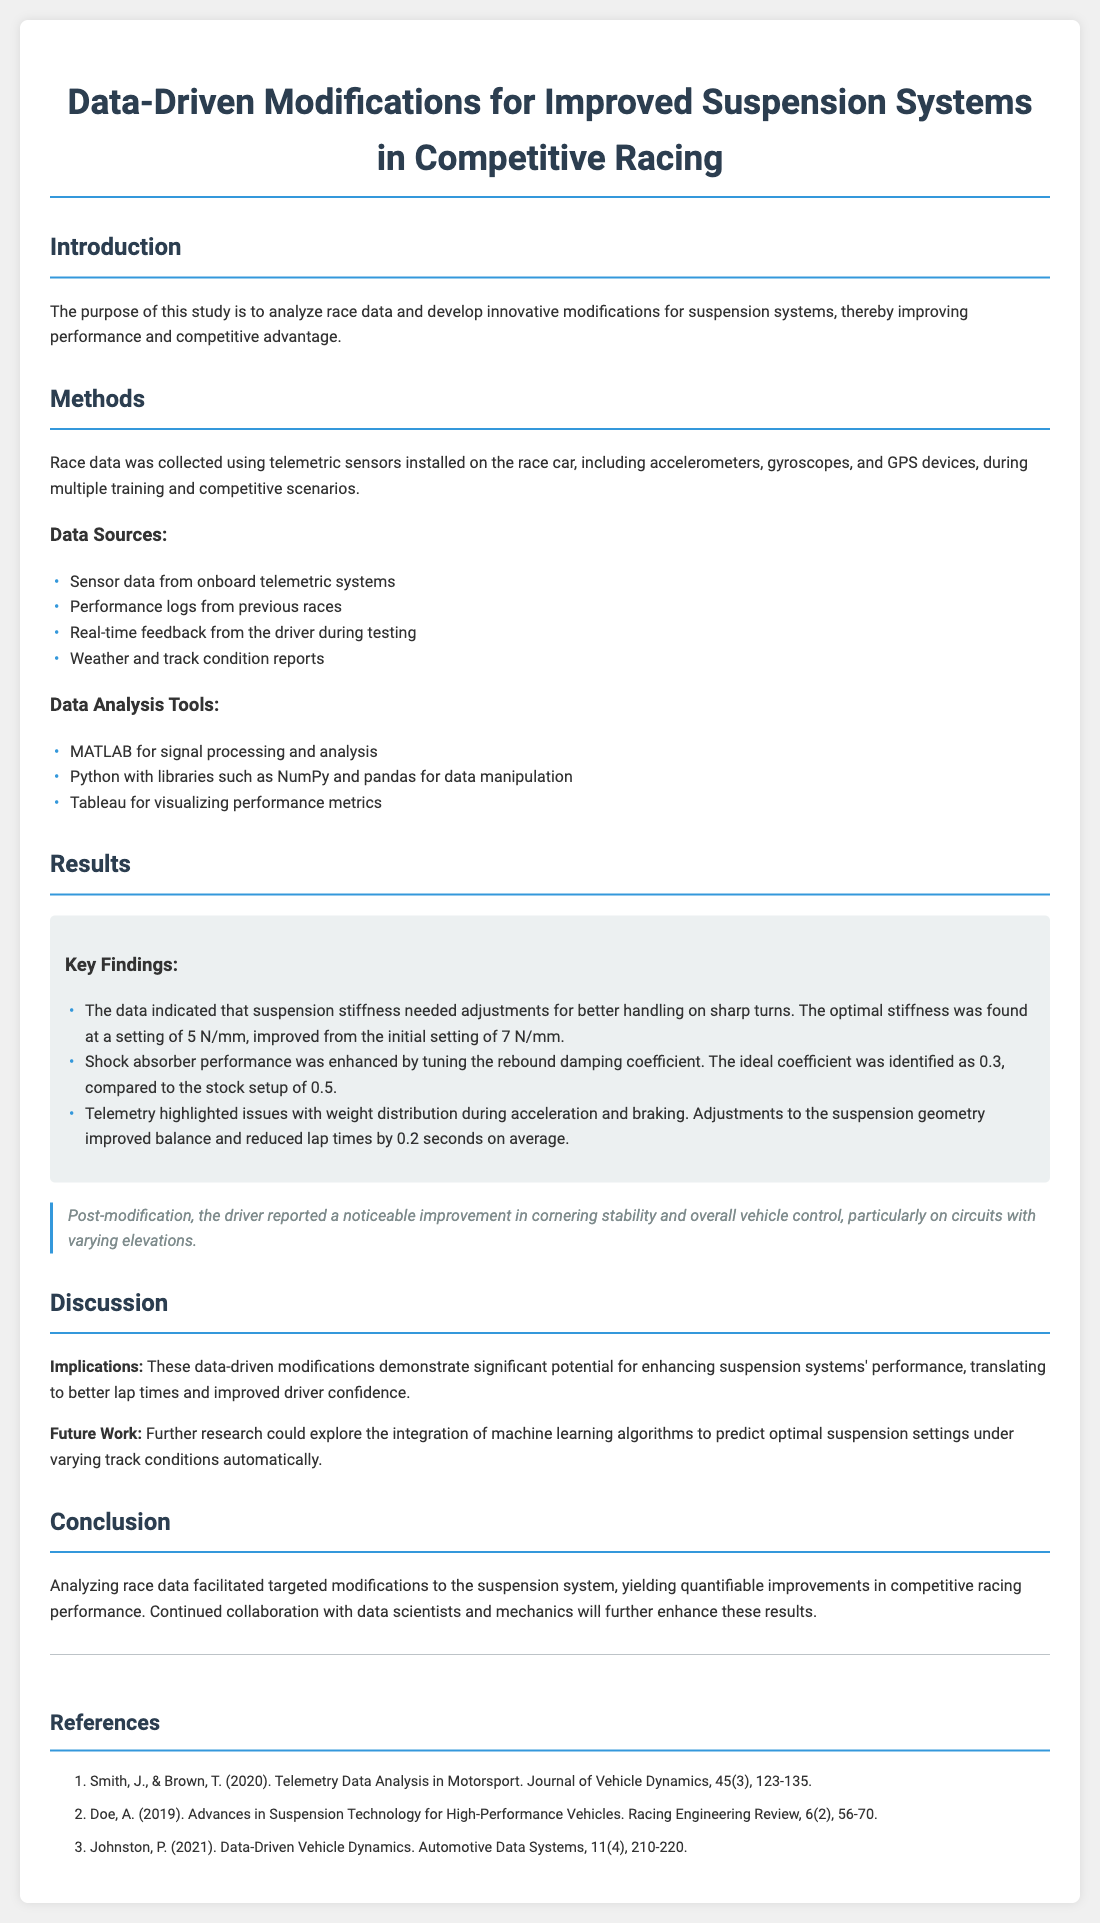What was the purpose of the study? The purpose of the study is outlined in the introduction, emphasizing the analysis of race data and the development of modifications for improved performance.
Answer: Analyze race data and develop modifications What tools were used for data analysis? The document outlines the tools used for analysis, including MATLAB, Python, and Tableau.
Answer: MATLAB, Python, Tableau What was the optimal suspension stiffness setting? The key findings section specifies the optimal stiffness setting needed for better handling on sharp turns.
Answer: 5 N/mm What adjustment improved shock absorber performance? The key findings indicate that tuning the rebound damping coefficient was essential for enhancing shock absorber performance.
Answer: Rebound damping coefficient By how much did lap times improve on average after modifications? The key findings provide a specific quantitative improvement in lap times as a result of modifications to the suspension system.
Answer: 0.2 seconds What feedback did the driver provide post-modification? The document contains a dedicated section for driver feedback, highlighting the perceived changes in vehicle control after modifications.
Answer: Noticeable improvement in cornering stability What is suggested for future research? The discussion section proposes new avenues for research to explore enhancements in suspension systems using advanced technology.
Answer: Integration of machine learning algorithms Which reference discusses telemetry data analysis? The references include several relevant works, and one specifically focuses on telemetry data analysis in motorsport.
Answer: Smith, J., & Brown, T. (2020) What year was the paper on advances in suspension technology published? The references provide publication details for each source, including the publication year for the paper on suspension technology.
Answer: 2019 